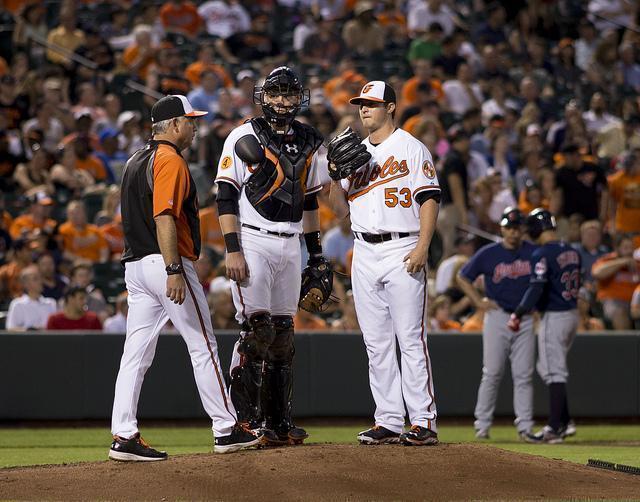Where are the three men in orange and white having their discussion?
Indicate the correct response by choosing from the four available options to answer the question.
Options: Homeplate, pitcher's mound, 2nd base, outfield. Pitcher's mound. 